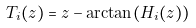<formula> <loc_0><loc_0><loc_500><loc_500>T _ { i } ( z ) = z - \arctan ( H _ { i } ( z ) )</formula> 